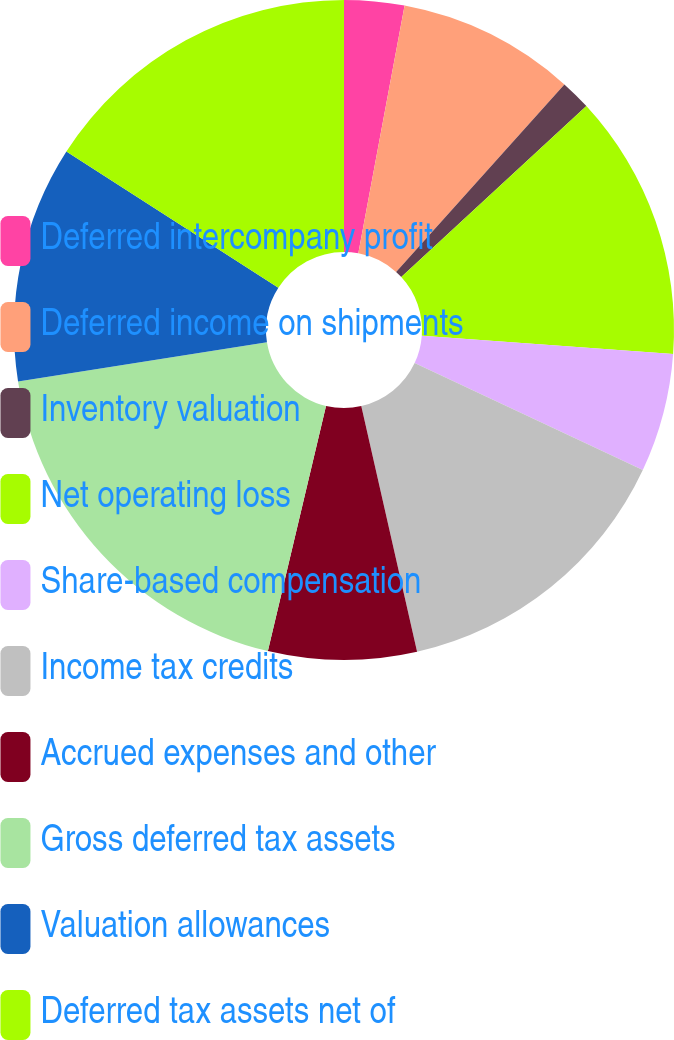Convert chart. <chart><loc_0><loc_0><loc_500><loc_500><pie_chart><fcel>Deferred intercompany profit<fcel>Deferred income on shipments<fcel>Inventory valuation<fcel>Net operating loss<fcel>Share-based compensation<fcel>Income tax credits<fcel>Accrued expenses and other<fcel>Gross deferred tax assets<fcel>Valuation allowances<fcel>Deferred tax assets net of<nl><fcel>2.94%<fcel>8.7%<fcel>1.49%<fcel>13.03%<fcel>5.82%<fcel>14.47%<fcel>7.26%<fcel>18.8%<fcel>11.59%<fcel>15.91%<nl></chart> 